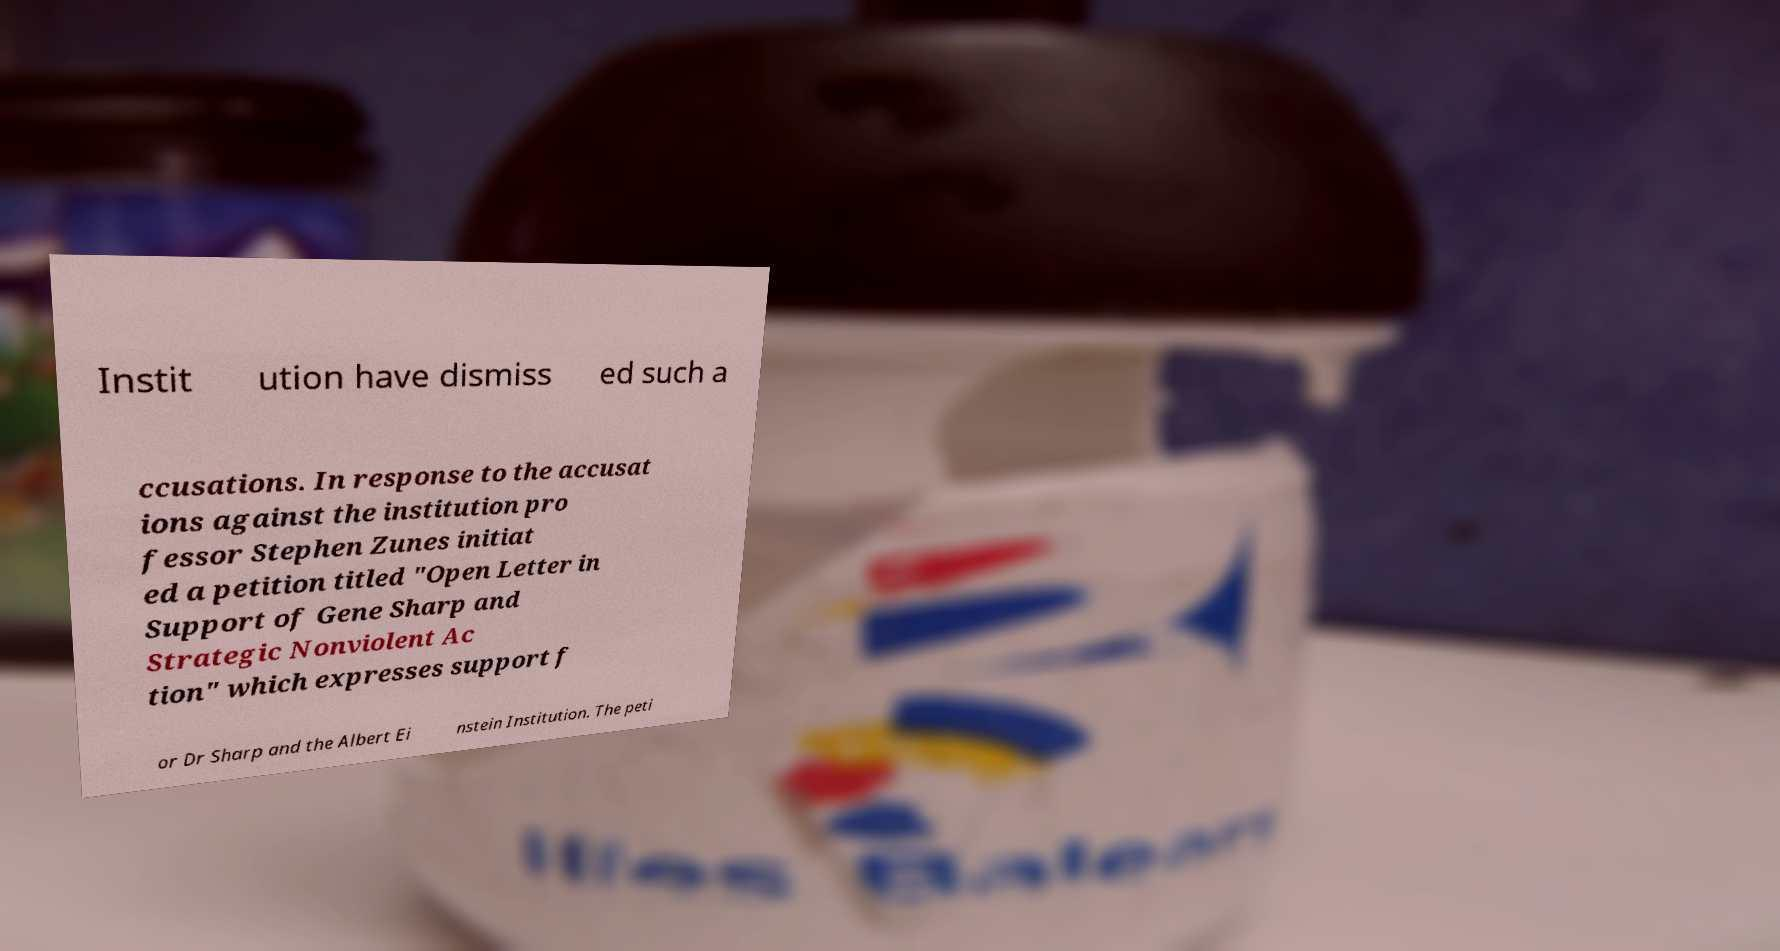For documentation purposes, I need the text within this image transcribed. Could you provide that? Instit ution have dismiss ed such a ccusations. In response to the accusat ions against the institution pro fessor Stephen Zunes initiat ed a petition titled "Open Letter in Support of Gene Sharp and Strategic Nonviolent Ac tion" which expresses support f or Dr Sharp and the Albert Ei nstein Institution. The peti 